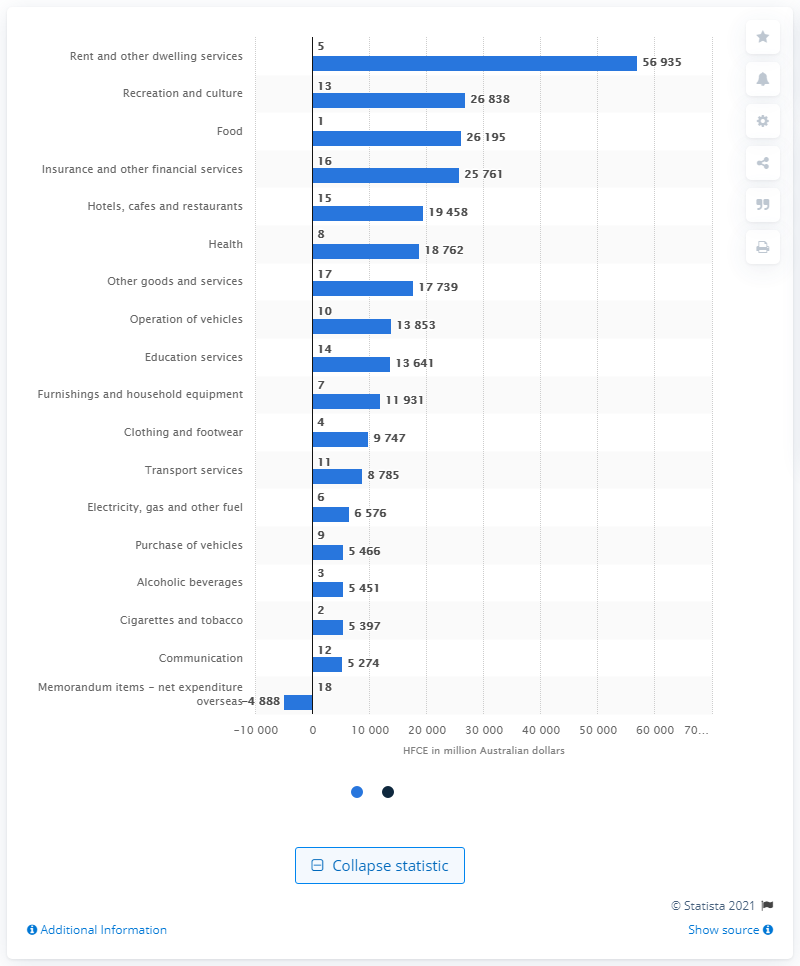List a handful of essential elements in this visual. In the fourth quarter of 2019, the household final consumption expenditure for rent and other dwelling services was 56,935. The second highest expenditure for rent and dwelling services in the fourth quarter of 2019 was for recreation and culture. 